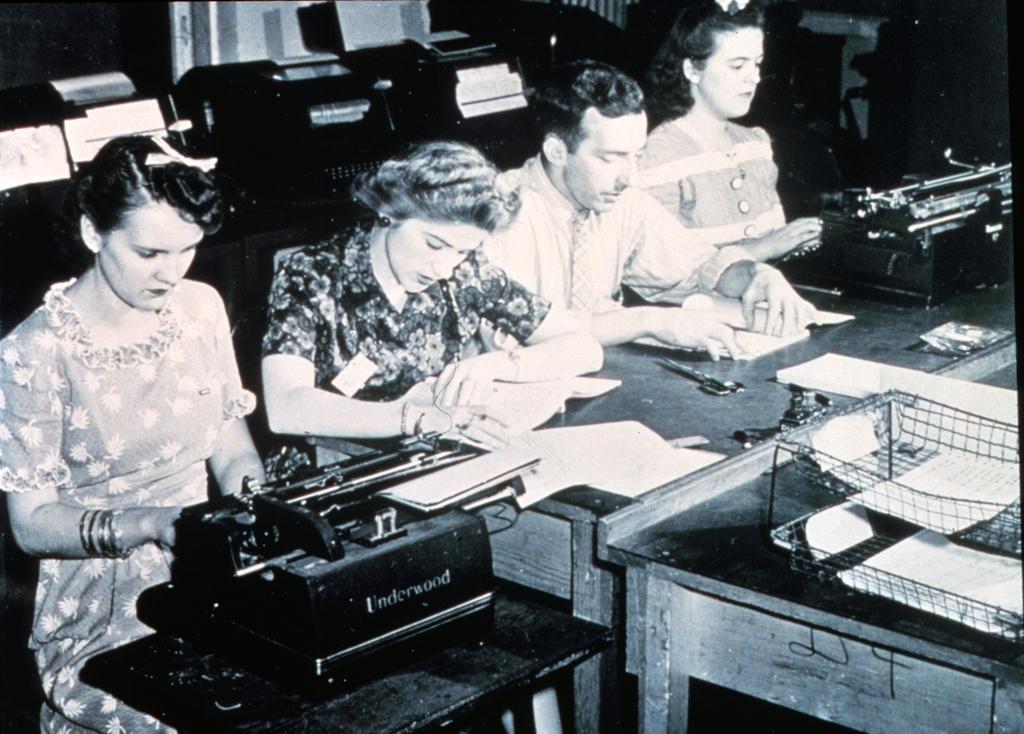In one or two sentences, can you explain what this image depicts? In the image we can see there are people sitting on the chair and there is typewriter kept on the table. There are papers kept on the table and behind there are typewriter machines kept on the table. The image is in black and white colour. 